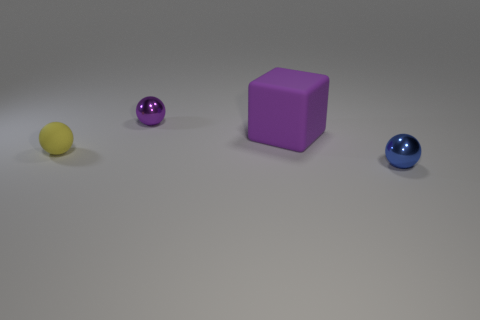What size is the ball that is the same color as the large matte block?
Your response must be concise. Small. There is another shiny sphere that is the same size as the purple metal sphere; what color is it?
Make the answer very short. Blue. How many other things are the same shape as the small rubber object?
Make the answer very short. 2. Is the size of the purple metal sphere the same as the blue shiny sphere?
Offer a very short reply. Yes. Is the number of blue objects in front of the tiny purple object greater than the number of purple things that are left of the large rubber cube?
Offer a terse response. No. What number of other objects are there of the same size as the rubber block?
Your answer should be compact. 0. There is a shiny object that is in front of the large purple object; does it have the same color as the small rubber sphere?
Give a very brief answer. No. Are there more blue things that are to the left of the purple metallic sphere than big green shiny objects?
Give a very brief answer. No. Is there anything else that has the same color as the large matte block?
Your answer should be very brief. Yes. There is a object to the left of the tiny metal object behind the small yellow sphere; what is its shape?
Provide a succinct answer. Sphere. 